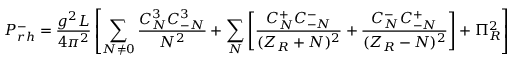<formula> <loc_0><loc_0><loc_500><loc_500>P _ { r h } ^ { - } = { \frac { g ^ { 2 } L } { 4 \pi ^ { 2 } } } \left [ \sum _ { N \neq 0 } { \frac { C _ { N } ^ { 3 } C _ { - N } ^ { 3 } } { N ^ { 2 } } } + \sum _ { N } \left [ { \frac { C _ { N } ^ { + } C _ { - N } ^ { - } } { ( Z _ { R } + N ) ^ { 2 } } } + { \frac { C _ { N } ^ { - } C _ { - N } ^ { + } } { ( Z _ { R } - N ) ^ { 2 } } } \right ] + \Pi _ { R } ^ { 2 } \right ]</formula> 